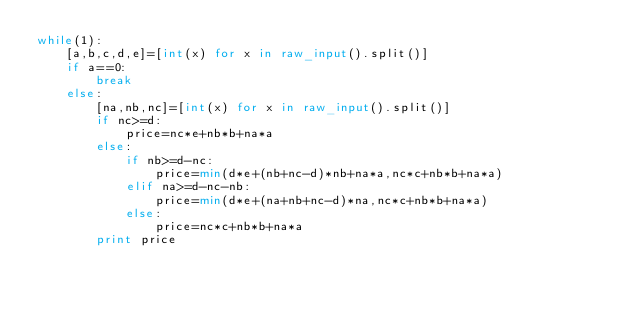Convert code to text. <code><loc_0><loc_0><loc_500><loc_500><_Python_>while(1):
    [a,b,c,d,e]=[int(x) for x in raw_input().split()]
    if a==0:
        break
    else:
        [na,nb,nc]=[int(x) for x in raw_input().split()]
        if nc>=d:
            price=nc*e+nb*b+na*a
        else:
            if nb>=d-nc:
                price=min(d*e+(nb+nc-d)*nb+na*a,nc*c+nb*b+na*a)
            elif na>=d-nc-nb:
                price=min(d*e+(na+nb+nc-d)*na,nc*c+nb*b+na*a)
            else:
                price=nc*c+nb*b+na*a
        print price</code> 